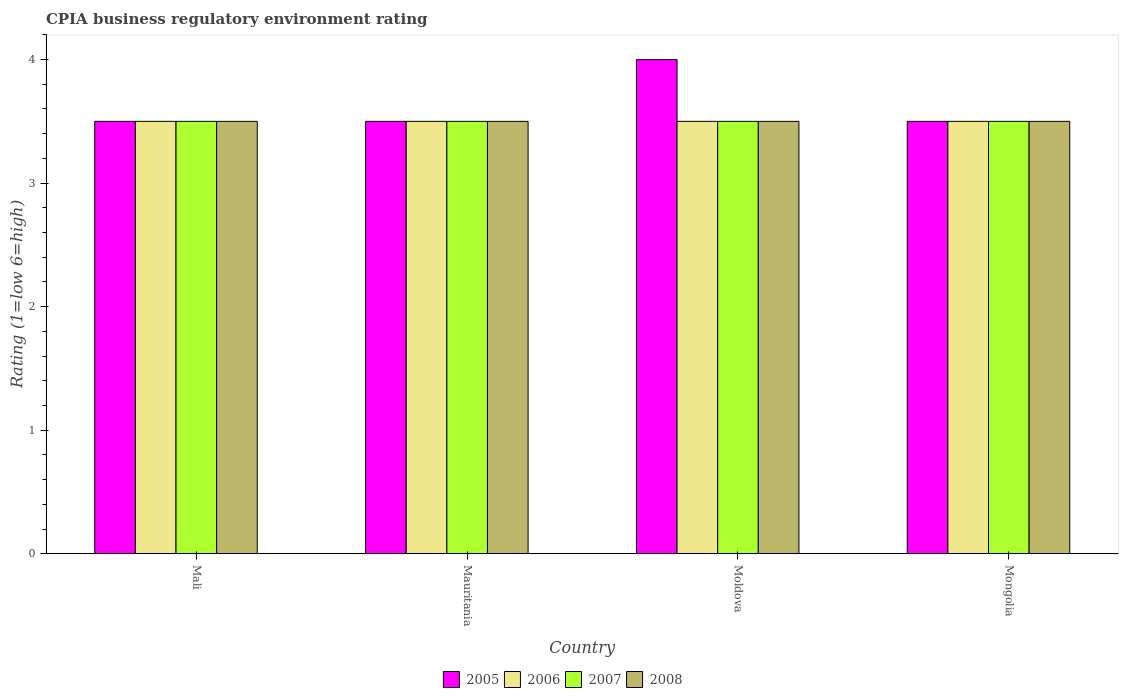How many groups of bars are there?
Your answer should be compact. 4. Are the number of bars on each tick of the X-axis equal?
Make the answer very short. Yes. What is the label of the 4th group of bars from the left?
Your answer should be very brief. Mongolia. Across all countries, what is the minimum CPIA rating in 2008?
Your answer should be compact. 3.5. In which country was the CPIA rating in 2008 maximum?
Provide a succinct answer. Mali. In which country was the CPIA rating in 2007 minimum?
Ensure brevity in your answer.  Mali. What is the difference between the CPIA rating in 2005 in Mauritania and that in Mongolia?
Your answer should be very brief. 0. What is the average CPIA rating in 2005 per country?
Offer a terse response. 3.62. What is the difference between the CPIA rating of/in 2007 and CPIA rating of/in 2006 in Mauritania?
Your answer should be compact. 0. In how many countries, is the CPIA rating in 2006 greater than 1.6?
Provide a succinct answer. 4. What is the ratio of the CPIA rating in 2008 in Mali to that in Moldova?
Keep it short and to the point. 1. Is the difference between the CPIA rating in 2007 in Mauritania and Mongolia greater than the difference between the CPIA rating in 2006 in Mauritania and Mongolia?
Your answer should be very brief. No. What is the difference between the highest and the second highest CPIA rating in 2005?
Offer a terse response. -0.5. What is the difference between the highest and the lowest CPIA rating in 2006?
Your response must be concise. 0. In how many countries, is the CPIA rating in 2007 greater than the average CPIA rating in 2007 taken over all countries?
Offer a terse response. 0. What does the 4th bar from the right in Mauritania represents?
Keep it short and to the point. 2005. Are all the bars in the graph horizontal?
Your response must be concise. No. Does the graph contain grids?
Ensure brevity in your answer.  No. What is the title of the graph?
Make the answer very short. CPIA business regulatory environment rating. What is the label or title of the X-axis?
Make the answer very short. Country. What is the Rating (1=low 6=high) of 2005 in Mauritania?
Your response must be concise. 3.5. What is the Rating (1=low 6=high) of 2007 in Mauritania?
Offer a very short reply. 3.5. What is the Rating (1=low 6=high) in 2006 in Moldova?
Provide a short and direct response. 3.5. What is the Rating (1=low 6=high) of 2008 in Mongolia?
Offer a terse response. 3.5. Across all countries, what is the maximum Rating (1=low 6=high) in 2008?
Offer a very short reply. 3.5. Across all countries, what is the minimum Rating (1=low 6=high) in 2007?
Ensure brevity in your answer.  3.5. What is the total Rating (1=low 6=high) of 2005 in the graph?
Offer a terse response. 14.5. What is the total Rating (1=low 6=high) of 2006 in the graph?
Make the answer very short. 14. What is the total Rating (1=low 6=high) of 2007 in the graph?
Give a very brief answer. 14. What is the difference between the Rating (1=low 6=high) of 2007 in Mali and that in Mauritania?
Your answer should be compact. 0. What is the difference between the Rating (1=low 6=high) in 2005 in Mali and that in Moldova?
Your answer should be very brief. -0.5. What is the difference between the Rating (1=low 6=high) in 2006 in Mali and that in Mongolia?
Your answer should be compact. 0. What is the difference between the Rating (1=low 6=high) of 2008 in Mali and that in Mongolia?
Offer a very short reply. 0. What is the difference between the Rating (1=low 6=high) in 2005 in Mauritania and that in Moldova?
Give a very brief answer. -0.5. What is the difference between the Rating (1=low 6=high) of 2008 in Mauritania and that in Moldova?
Provide a short and direct response. 0. What is the difference between the Rating (1=low 6=high) in 2005 in Mauritania and that in Mongolia?
Your response must be concise. 0. What is the difference between the Rating (1=low 6=high) of 2006 in Mauritania and that in Mongolia?
Give a very brief answer. 0. What is the difference between the Rating (1=low 6=high) of 2007 in Mauritania and that in Mongolia?
Offer a very short reply. 0. What is the difference between the Rating (1=low 6=high) in 2008 in Mauritania and that in Mongolia?
Offer a terse response. 0. What is the difference between the Rating (1=low 6=high) in 2006 in Moldova and that in Mongolia?
Your answer should be very brief. 0. What is the difference between the Rating (1=low 6=high) of 2007 in Moldova and that in Mongolia?
Offer a terse response. 0. What is the difference between the Rating (1=low 6=high) of 2008 in Moldova and that in Mongolia?
Your answer should be compact. 0. What is the difference between the Rating (1=low 6=high) in 2005 in Mali and the Rating (1=low 6=high) in 2006 in Mauritania?
Provide a short and direct response. 0. What is the difference between the Rating (1=low 6=high) of 2005 in Mali and the Rating (1=low 6=high) of 2007 in Mauritania?
Offer a very short reply. 0. What is the difference between the Rating (1=low 6=high) in 2005 in Mali and the Rating (1=low 6=high) in 2008 in Mauritania?
Provide a succinct answer. 0. What is the difference between the Rating (1=low 6=high) of 2006 in Mali and the Rating (1=low 6=high) of 2007 in Mauritania?
Give a very brief answer. 0. What is the difference between the Rating (1=low 6=high) in 2006 in Mali and the Rating (1=low 6=high) in 2008 in Mauritania?
Offer a very short reply. 0. What is the difference between the Rating (1=low 6=high) of 2005 in Mali and the Rating (1=low 6=high) of 2006 in Moldova?
Your answer should be compact. 0. What is the difference between the Rating (1=low 6=high) of 2005 in Mali and the Rating (1=low 6=high) of 2007 in Moldova?
Provide a succinct answer. 0. What is the difference between the Rating (1=low 6=high) of 2006 in Mali and the Rating (1=low 6=high) of 2007 in Moldova?
Ensure brevity in your answer.  0. What is the difference between the Rating (1=low 6=high) in 2007 in Mali and the Rating (1=low 6=high) in 2008 in Moldova?
Make the answer very short. 0. What is the difference between the Rating (1=low 6=high) in 2005 in Mali and the Rating (1=low 6=high) in 2007 in Mongolia?
Provide a succinct answer. 0. What is the difference between the Rating (1=low 6=high) of 2006 in Mali and the Rating (1=low 6=high) of 2007 in Mongolia?
Your answer should be very brief. 0. What is the difference between the Rating (1=low 6=high) of 2006 in Mali and the Rating (1=low 6=high) of 2008 in Mongolia?
Offer a very short reply. 0. What is the difference between the Rating (1=low 6=high) of 2007 in Mali and the Rating (1=low 6=high) of 2008 in Mongolia?
Provide a succinct answer. 0. What is the difference between the Rating (1=low 6=high) in 2005 in Mauritania and the Rating (1=low 6=high) in 2006 in Moldova?
Your response must be concise. 0. What is the difference between the Rating (1=low 6=high) in 2005 in Mauritania and the Rating (1=low 6=high) in 2008 in Moldova?
Make the answer very short. 0. What is the difference between the Rating (1=low 6=high) of 2007 in Mauritania and the Rating (1=low 6=high) of 2008 in Moldova?
Provide a short and direct response. 0. What is the difference between the Rating (1=low 6=high) of 2005 in Mauritania and the Rating (1=low 6=high) of 2006 in Mongolia?
Provide a short and direct response. 0. What is the difference between the Rating (1=low 6=high) in 2005 in Mauritania and the Rating (1=low 6=high) in 2008 in Mongolia?
Keep it short and to the point. 0. What is the difference between the Rating (1=low 6=high) in 2006 in Mauritania and the Rating (1=low 6=high) in 2007 in Mongolia?
Your answer should be compact. 0. What is the difference between the Rating (1=low 6=high) of 2005 in Moldova and the Rating (1=low 6=high) of 2006 in Mongolia?
Provide a succinct answer. 0.5. What is the average Rating (1=low 6=high) of 2005 per country?
Ensure brevity in your answer.  3.62. What is the average Rating (1=low 6=high) in 2008 per country?
Keep it short and to the point. 3.5. What is the difference between the Rating (1=low 6=high) in 2005 and Rating (1=low 6=high) in 2007 in Mali?
Ensure brevity in your answer.  0. What is the difference between the Rating (1=low 6=high) of 2006 and Rating (1=low 6=high) of 2008 in Mali?
Provide a succinct answer. 0. What is the difference between the Rating (1=low 6=high) in 2005 and Rating (1=low 6=high) in 2007 in Mauritania?
Keep it short and to the point. 0. What is the difference between the Rating (1=low 6=high) in 2006 and Rating (1=low 6=high) in 2007 in Mauritania?
Give a very brief answer. 0. What is the difference between the Rating (1=low 6=high) of 2005 and Rating (1=low 6=high) of 2007 in Moldova?
Your response must be concise. 0.5. What is the difference between the Rating (1=low 6=high) in 2005 and Rating (1=low 6=high) in 2006 in Mongolia?
Your answer should be very brief. 0. What is the difference between the Rating (1=low 6=high) in 2005 and Rating (1=low 6=high) in 2007 in Mongolia?
Your response must be concise. 0. What is the difference between the Rating (1=low 6=high) of 2006 and Rating (1=low 6=high) of 2007 in Mongolia?
Offer a terse response. 0. What is the ratio of the Rating (1=low 6=high) of 2005 in Mali to that in Mauritania?
Provide a short and direct response. 1. What is the ratio of the Rating (1=low 6=high) in 2007 in Mali to that in Mauritania?
Offer a very short reply. 1. What is the ratio of the Rating (1=low 6=high) in 2005 in Mali to that in Moldova?
Offer a terse response. 0.88. What is the ratio of the Rating (1=low 6=high) of 2007 in Mali to that in Moldova?
Your answer should be very brief. 1. What is the ratio of the Rating (1=low 6=high) of 2005 in Mali to that in Mongolia?
Offer a very short reply. 1. What is the ratio of the Rating (1=low 6=high) in 2007 in Mali to that in Mongolia?
Your answer should be very brief. 1. What is the ratio of the Rating (1=low 6=high) in 2008 in Mali to that in Mongolia?
Offer a terse response. 1. What is the ratio of the Rating (1=low 6=high) in 2005 in Mauritania to that in Moldova?
Give a very brief answer. 0.88. What is the ratio of the Rating (1=low 6=high) of 2007 in Mauritania to that in Moldova?
Provide a succinct answer. 1. What is the ratio of the Rating (1=low 6=high) in 2007 in Mauritania to that in Mongolia?
Your response must be concise. 1. What is the ratio of the Rating (1=low 6=high) in 2008 in Mauritania to that in Mongolia?
Ensure brevity in your answer.  1. What is the ratio of the Rating (1=low 6=high) of 2005 in Moldova to that in Mongolia?
Your answer should be very brief. 1.14. What is the ratio of the Rating (1=low 6=high) in 2006 in Moldova to that in Mongolia?
Ensure brevity in your answer.  1. What is the ratio of the Rating (1=low 6=high) in 2007 in Moldova to that in Mongolia?
Your response must be concise. 1. What is the difference between the highest and the second highest Rating (1=low 6=high) of 2005?
Your answer should be very brief. 0.5. What is the difference between the highest and the second highest Rating (1=low 6=high) of 2006?
Provide a succinct answer. 0. What is the difference between the highest and the second highest Rating (1=low 6=high) of 2007?
Your answer should be very brief. 0. What is the difference between the highest and the lowest Rating (1=low 6=high) in 2005?
Your answer should be compact. 0.5. What is the difference between the highest and the lowest Rating (1=low 6=high) of 2006?
Your answer should be compact. 0. 